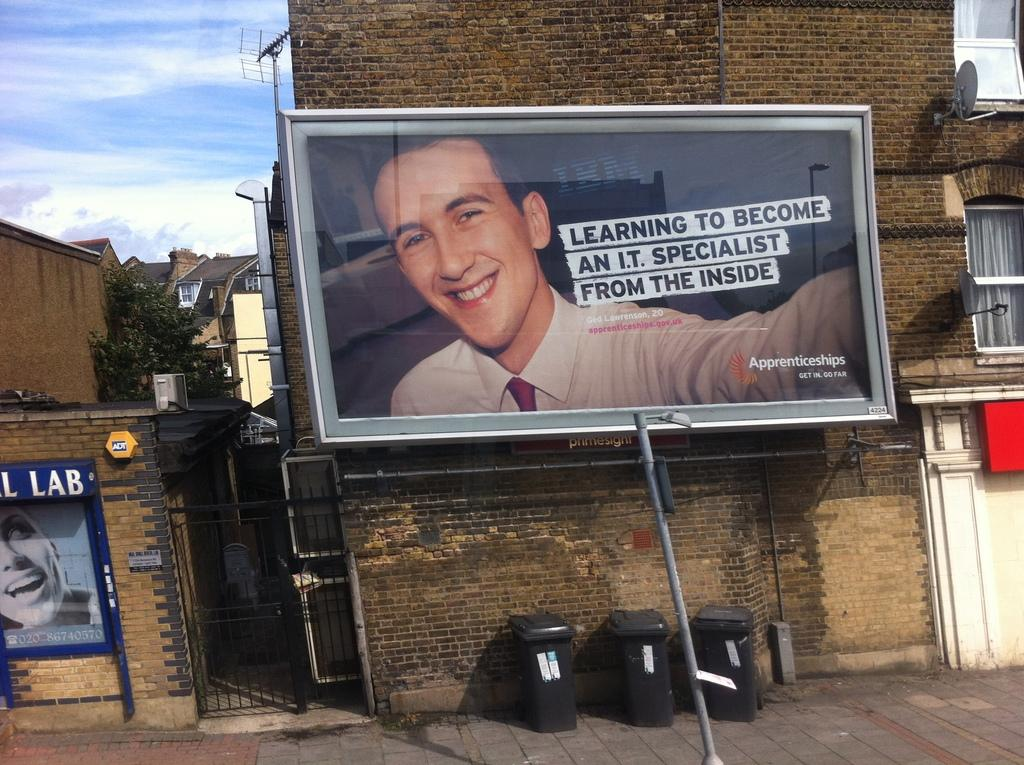<image>
Create a compact narrative representing the image presented. an advertisement on a brick wall about becoming an I.T. specialist 